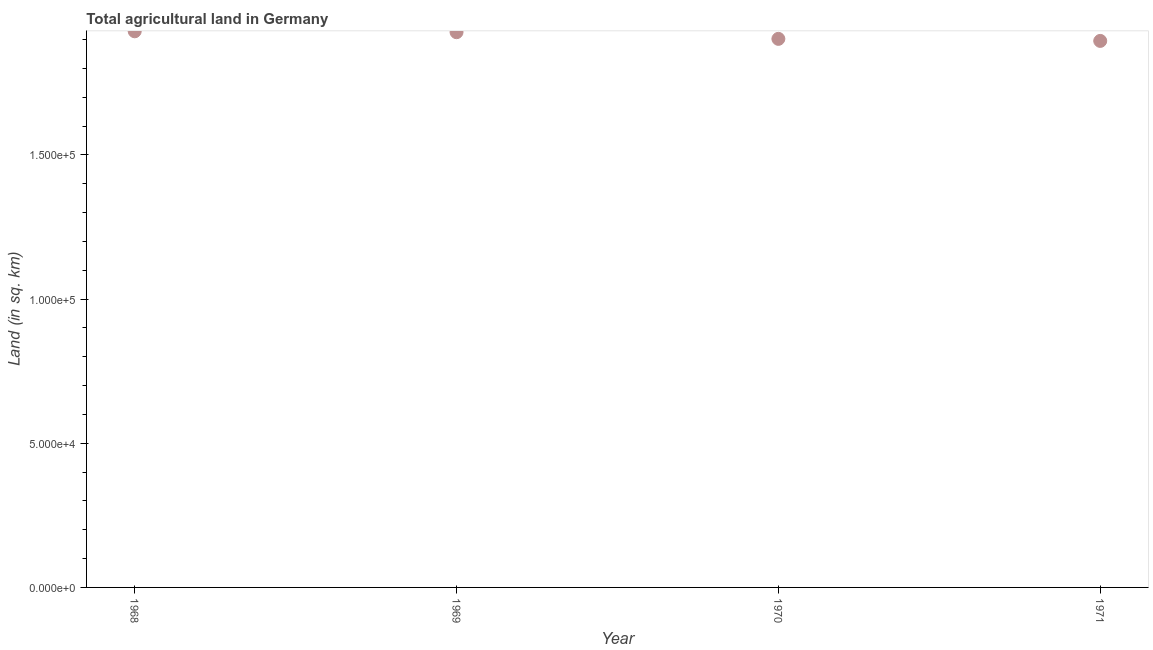What is the agricultural land in 1970?
Make the answer very short. 1.90e+05. Across all years, what is the maximum agricultural land?
Your answer should be very brief. 1.93e+05. Across all years, what is the minimum agricultural land?
Provide a short and direct response. 1.90e+05. In which year was the agricultural land maximum?
Provide a short and direct response. 1968. In which year was the agricultural land minimum?
Your answer should be compact. 1971. What is the sum of the agricultural land?
Offer a very short reply. 7.65e+05. What is the difference between the agricultural land in 1970 and 1971?
Provide a short and direct response. 710. What is the average agricultural land per year?
Provide a succinct answer. 1.91e+05. What is the median agricultural land?
Ensure brevity in your answer.  1.91e+05. What is the ratio of the agricultural land in 1969 to that in 1971?
Your response must be concise. 1.02. Is the agricultural land in 1968 less than that in 1970?
Make the answer very short. No. Is the difference between the agricultural land in 1969 and 1970 greater than the difference between any two years?
Make the answer very short. No. What is the difference between the highest and the second highest agricultural land?
Give a very brief answer. 310. What is the difference between the highest and the lowest agricultural land?
Offer a terse response. 3330. How many dotlines are there?
Give a very brief answer. 1. What is the difference between two consecutive major ticks on the Y-axis?
Your answer should be compact. 5.00e+04. Are the values on the major ticks of Y-axis written in scientific E-notation?
Your answer should be very brief. Yes. What is the title of the graph?
Keep it short and to the point. Total agricultural land in Germany. What is the label or title of the Y-axis?
Provide a short and direct response. Land (in sq. km). What is the Land (in sq. km) in 1968?
Keep it short and to the point. 1.93e+05. What is the Land (in sq. km) in 1969?
Offer a very short reply. 1.93e+05. What is the Land (in sq. km) in 1970?
Keep it short and to the point. 1.90e+05. What is the Land (in sq. km) in 1971?
Offer a very short reply. 1.90e+05. What is the difference between the Land (in sq. km) in 1968 and 1969?
Your response must be concise. 310. What is the difference between the Land (in sq. km) in 1968 and 1970?
Provide a succinct answer. 2620. What is the difference between the Land (in sq. km) in 1968 and 1971?
Your answer should be very brief. 3330. What is the difference between the Land (in sq. km) in 1969 and 1970?
Your response must be concise. 2310. What is the difference between the Land (in sq. km) in 1969 and 1971?
Make the answer very short. 3020. What is the difference between the Land (in sq. km) in 1970 and 1971?
Provide a succinct answer. 710. What is the ratio of the Land (in sq. km) in 1968 to that in 1970?
Offer a terse response. 1.01. What is the ratio of the Land (in sq. km) in 1969 to that in 1970?
Keep it short and to the point. 1.01. What is the ratio of the Land (in sq. km) in 1969 to that in 1971?
Provide a short and direct response. 1.02. 